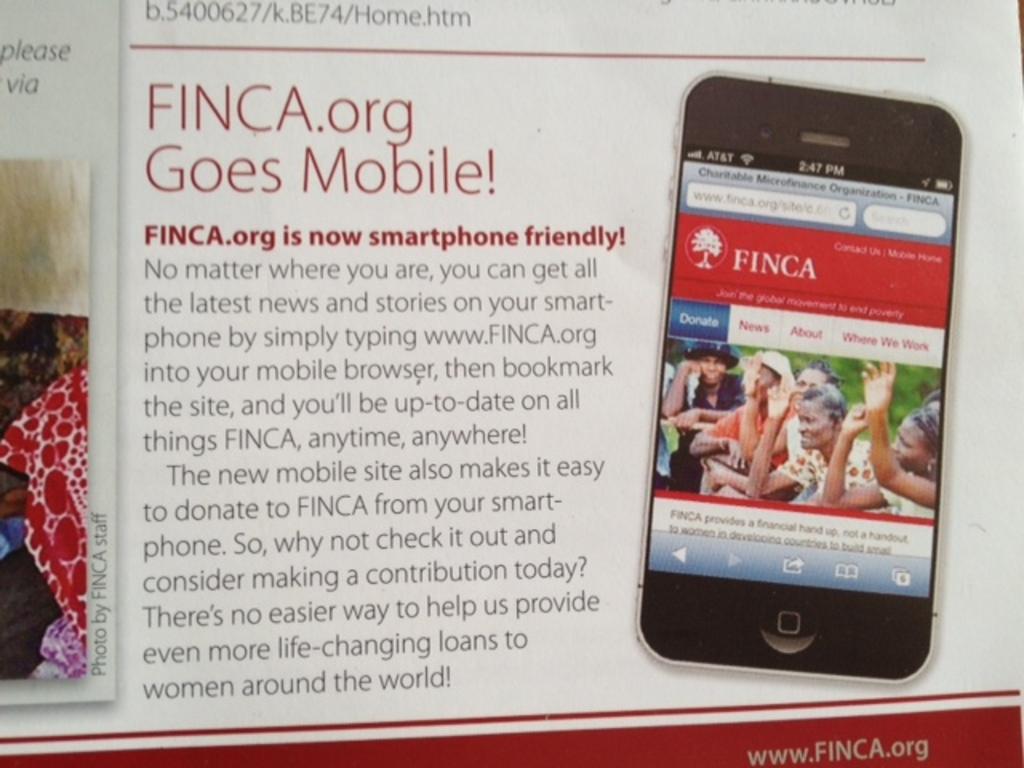What kind of news does finca provide?
Provide a short and direct response. Latest. What is finca now friendly with?
Your response must be concise. Smartphone. 